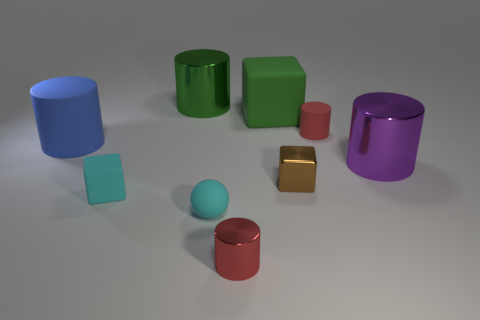There is a blue cylinder that is the same material as the small sphere; what is its size?
Give a very brief answer. Large. There is a cyan block behind the cyan sphere; is it the same size as the purple cylinder?
Provide a succinct answer. No. What is the color of the tiny rubber thing that is the same shape as the big purple metallic object?
Offer a very short reply. Red. Is the rubber ball the same color as the small rubber cube?
Your response must be concise. Yes. There is a red shiny thing that is the same shape as the blue object; what size is it?
Offer a very short reply. Small. What size is the green rubber thing?
Keep it short and to the point. Large. There is a large object that is the same color as the big cube; what is it made of?
Provide a short and direct response. Metal. What number of tiny matte blocks are the same color as the ball?
Provide a succinct answer. 1. Is the matte sphere the same size as the green cylinder?
Make the answer very short. No. There is a object on the left side of the small block to the left of the large green metal cylinder; what is its size?
Provide a succinct answer. Large. 